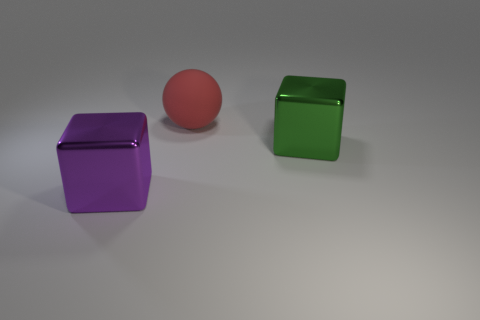Add 1 green shiny cubes. How many objects exist? 4 Subtract all green blocks. How many blocks are left? 1 Subtract 1 balls. How many balls are left? 0 Add 1 big metal cubes. How many big metal cubes are left? 3 Add 1 green things. How many green things exist? 2 Subtract 0 blue balls. How many objects are left? 3 Subtract all spheres. How many objects are left? 2 Subtract all yellow cubes. Subtract all blue balls. How many cubes are left? 2 Subtract all blue matte cylinders. Subtract all red objects. How many objects are left? 2 